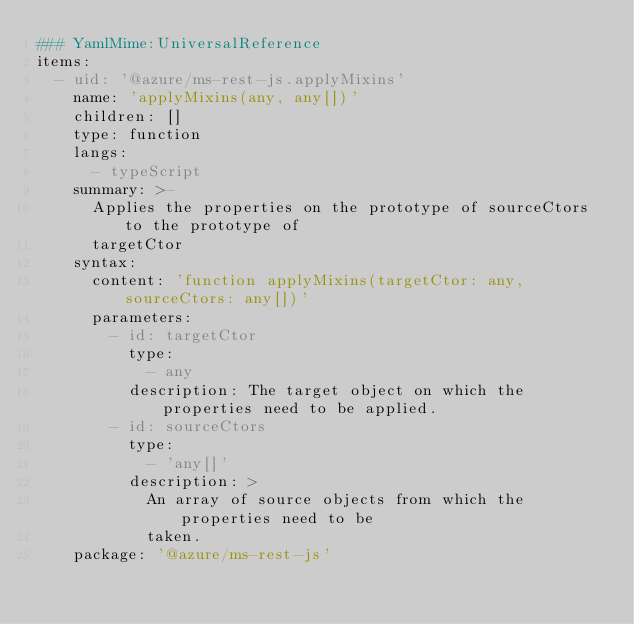<code> <loc_0><loc_0><loc_500><loc_500><_YAML_>### YamlMime:UniversalReference
items:
  - uid: '@azure/ms-rest-js.applyMixins'
    name: 'applyMixins(any, any[])'
    children: []
    type: function
    langs:
      - typeScript
    summary: >-
      Applies the properties on the prototype of sourceCtors to the prototype of
      targetCtor
    syntax:
      content: 'function applyMixins(targetCtor: any, sourceCtors: any[])'
      parameters:
        - id: targetCtor
          type:
            - any
          description: The target object on which the properties need to be applied.
        - id: sourceCtors
          type:
            - 'any[]'
          description: >
            An array of source objects from which the properties need to be
            taken.
    package: '@azure/ms-rest-js'
</code> 